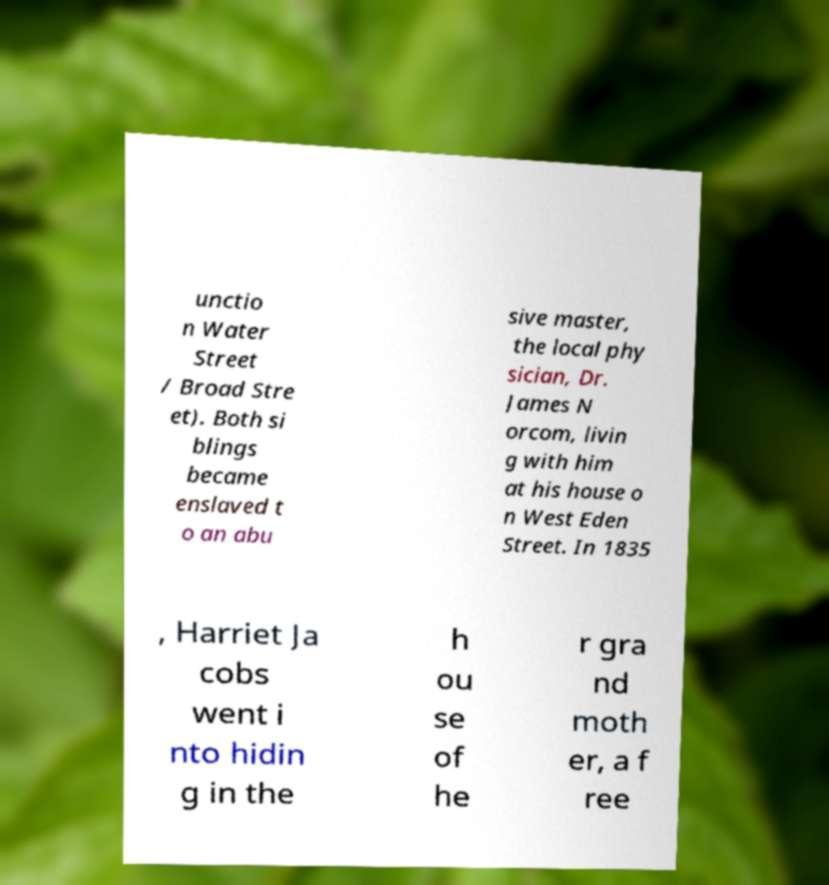Can you accurately transcribe the text from the provided image for me? unctio n Water Street / Broad Stre et). Both si blings became enslaved t o an abu sive master, the local phy sician, Dr. James N orcom, livin g with him at his house o n West Eden Street. In 1835 , Harriet Ja cobs went i nto hidin g in the h ou se of he r gra nd moth er, a f ree 